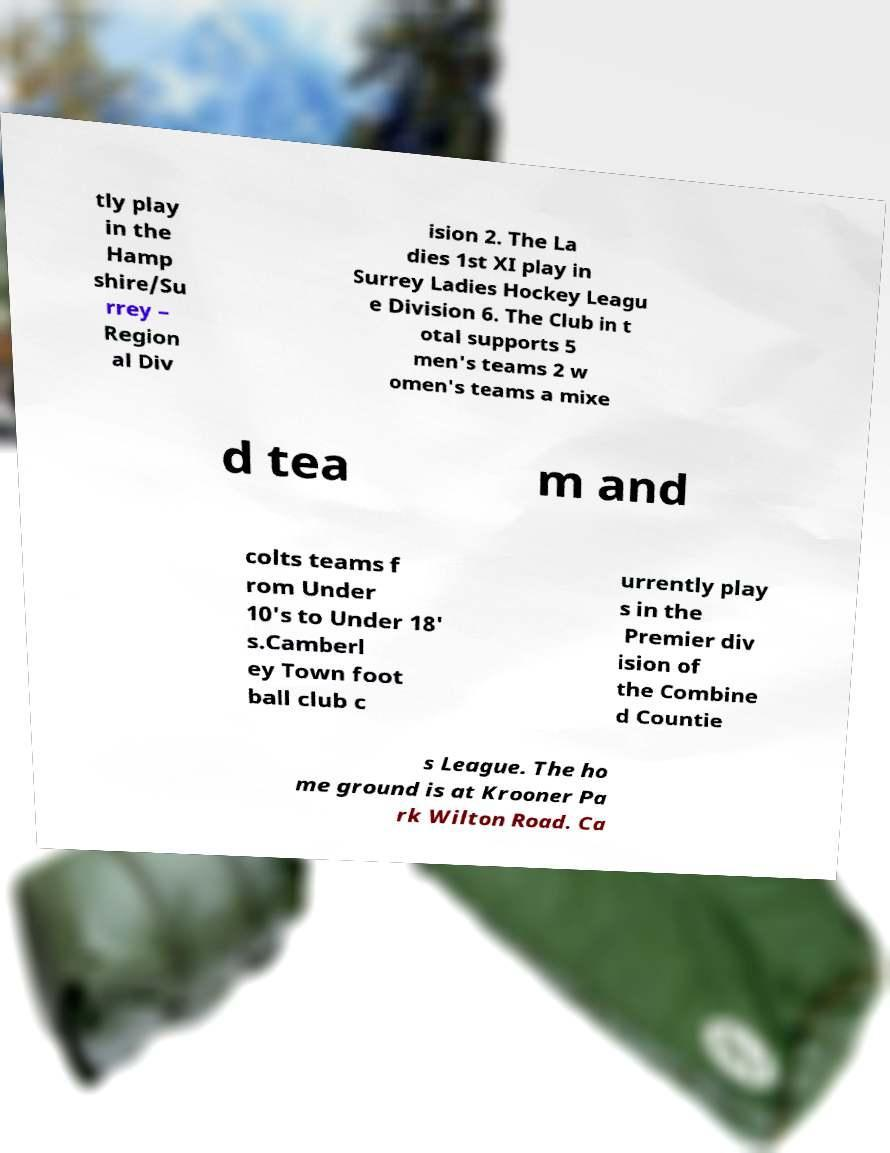Please identify and transcribe the text found in this image. tly play in the Hamp shire/Su rrey – Region al Div ision 2. The La dies 1st XI play in Surrey Ladies Hockey Leagu e Division 6. The Club in t otal supports 5 men's teams 2 w omen's teams a mixe d tea m and colts teams f rom Under 10's to Under 18' s.Camberl ey Town foot ball club c urrently play s in the Premier div ision of the Combine d Countie s League. The ho me ground is at Krooner Pa rk Wilton Road. Ca 